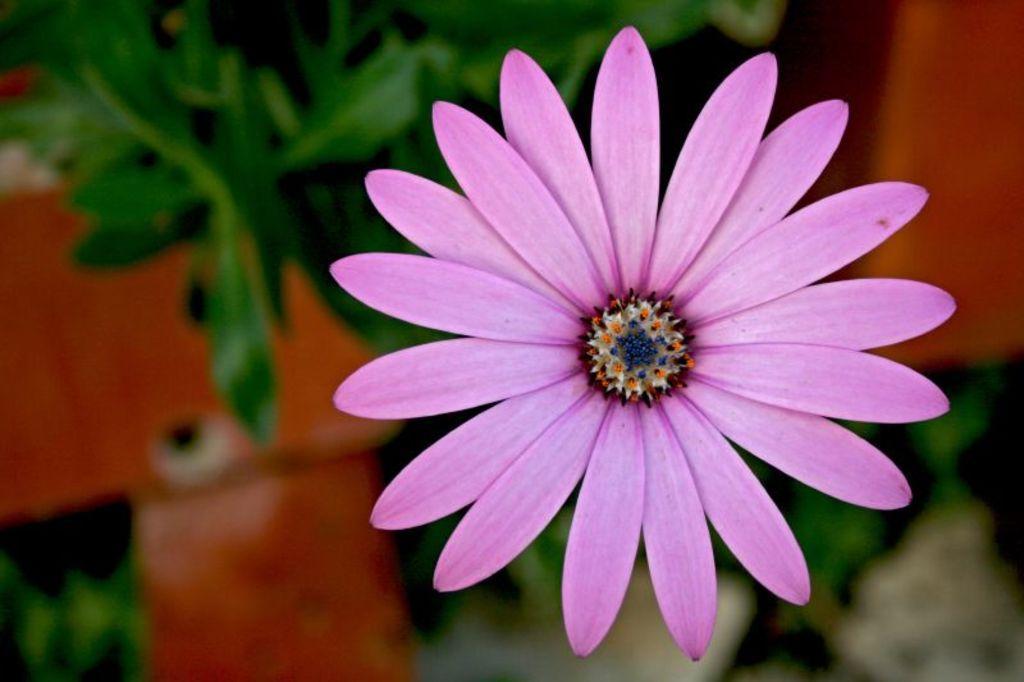How would you summarize this image in a sentence or two? We can see pink flower. Background it is green. 